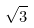<formula> <loc_0><loc_0><loc_500><loc_500>\sqrt { 3 }</formula> 